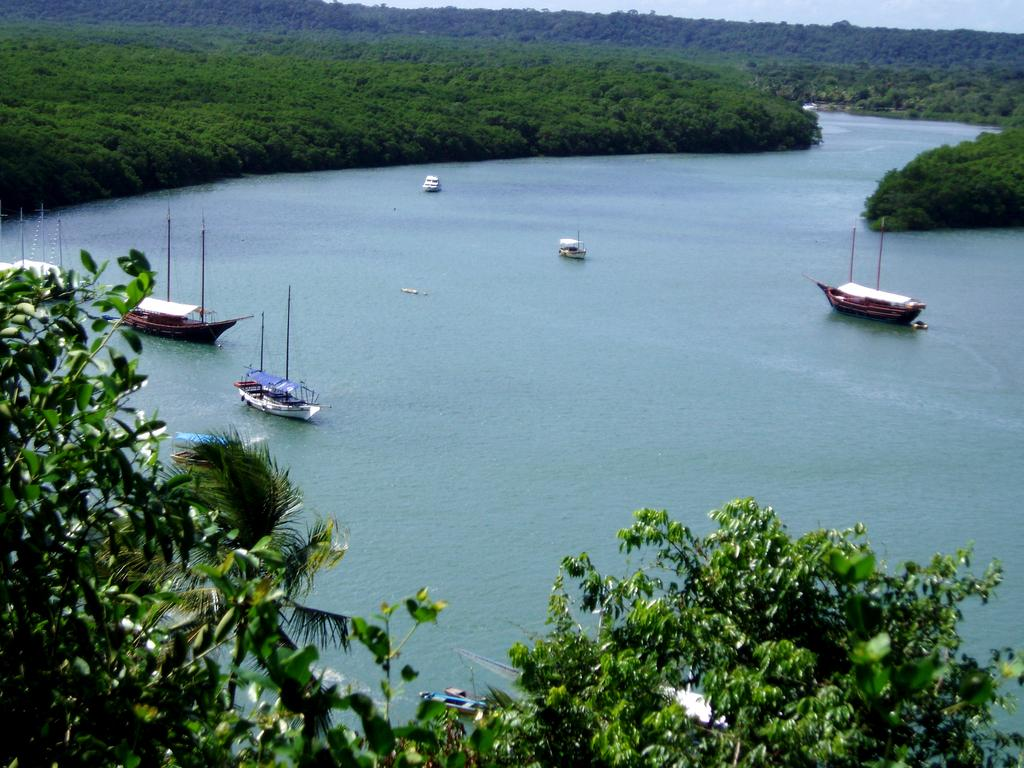What type of vehicles are in the water in the image? There are boats in the water in the image. What can be seen in the background of the image? Hills and the sky are visible at the top of the image. What type of vegetation is at the bottom of the image? There are trees at the bottom of the image. What type of history can be seen in the image? There is no specific historical event or reference visible in the image; it features boats in the water, hills, sky, and trees. Can you see your father's fang in the image? There is no reference to a fang or any person in the image, so it cannot be determined if your father's fang is present. 